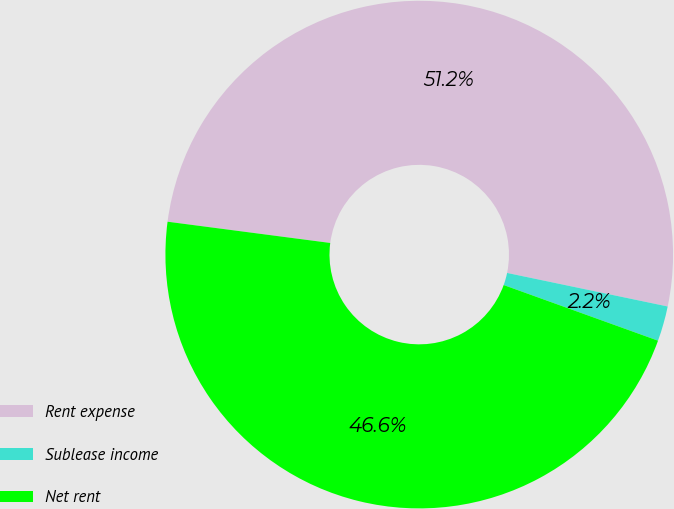Convert chart. <chart><loc_0><loc_0><loc_500><loc_500><pie_chart><fcel>Rent expense<fcel>Sublease income<fcel>Net rent<nl><fcel>51.21%<fcel>2.23%<fcel>46.56%<nl></chart> 